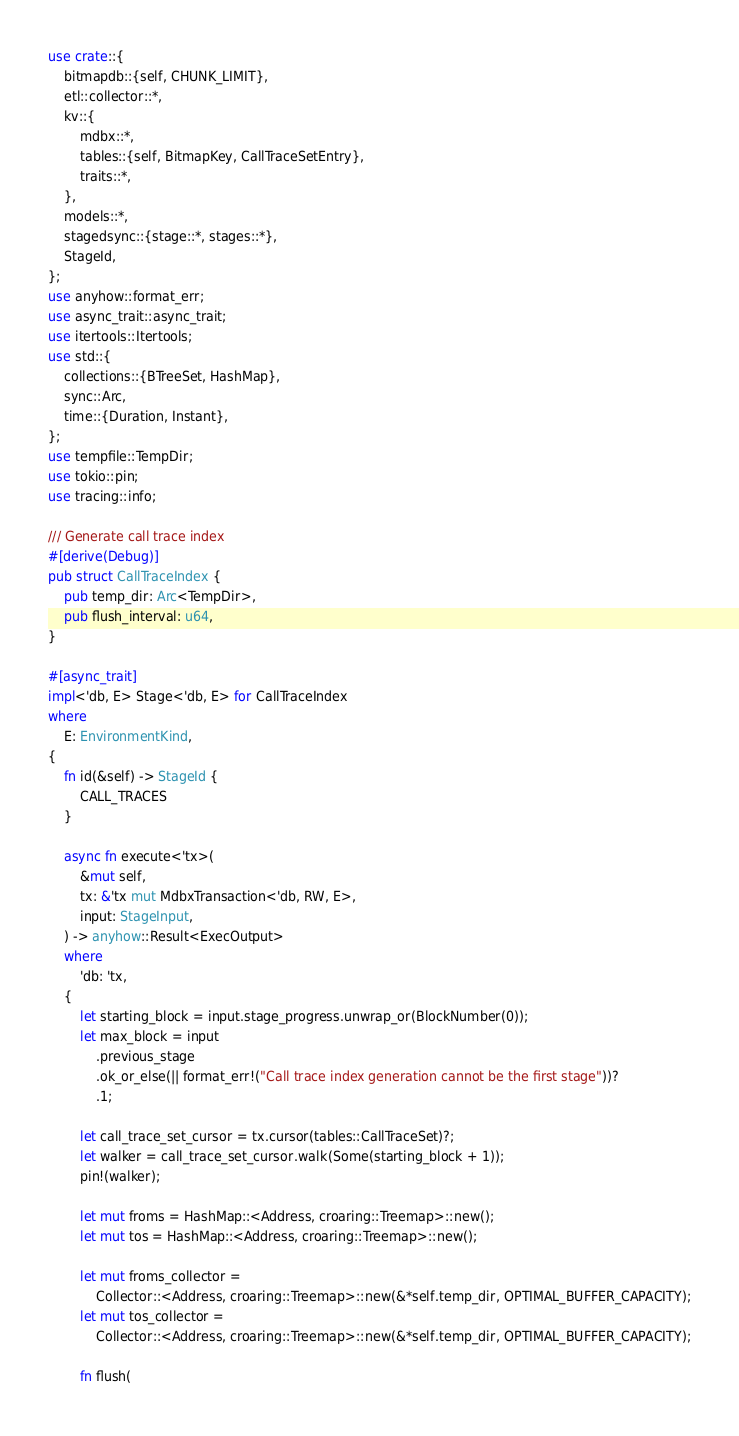<code> <loc_0><loc_0><loc_500><loc_500><_Rust_>use crate::{
    bitmapdb::{self, CHUNK_LIMIT},
    etl::collector::*,
    kv::{
        mdbx::*,
        tables::{self, BitmapKey, CallTraceSetEntry},
        traits::*,
    },
    models::*,
    stagedsync::{stage::*, stages::*},
    StageId,
};
use anyhow::format_err;
use async_trait::async_trait;
use itertools::Itertools;
use std::{
    collections::{BTreeSet, HashMap},
    sync::Arc,
    time::{Duration, Instant},
};
use tempfile::TempDir;
use tokio::pin;
use tracing::info;

/// Generate call trace index
#[derive(Debug)]
pub struct CallTraceIndex {
    pub temp_dir: Arc<TempDir>,
    pub flush_interval: u64,
}

#[async_trait]
impl<'db, E> Stage<'db, E> for CallTraceIndex
where
    E: EnvironmentKind,
{
    fn id(&self) -> StageId {
        CALL_TRACES
    }

    async fn execute<'tx>(
        &mut self,
        tx: &'tx mut MdbxTransaction<'db, RW, E>,
        input: StageInput,
    ) -> anyhow::Result<ExecOutput>
    where
        'db: 'tx,
    {
        let starting_block = input.stage_progress.unwrap_or(BlockNumber(0));
        let max_block = input
            .previous_stage
            .ok_or_else(|| format_err!("Call trace index generation cannot be the first stage"))?
            .1;

        let call_trace_set_cursor = tx.cursor(tables::CallTraceSet)?;
        let walker = call_trace_set_cursor.walk(Some(starting_block + 1));
        pin!(walker);

        let mut froms = HashMap::<Address, croaring::Treemap>::new();
        let mut tos = HashMap::<Address, croaring::Treemap>::new();

        let mut froms_collector =
            Collector::<Address, croaring::Treemap>::new(&*self.temp_dir, OPTIMAL_BUFFER_CAPACITY);
        let mut tos_collector =
            Collector::<Address, croaring::Treemap>::new(&*self.temp_dir, OPTIMAL_BUFFER_CAPACITY);

        fn flush(</code> 